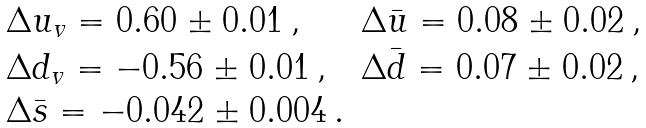Convert formula to latex. <formula><loc_0><loc_0><loc_500><loc_500>\begin{array} { l l } \Delta u _ { v } = 0 . 6 0 \pm 0 . 0 1 \, , & \Delta \bar { u } = 0 . 0 8 \pm 0 . 0 2 \, , \\ \Delta d _ { v } = - 0 . 5 6 \pm 0 . 0 1 \, , & \Delta \bar { d } = 0 . 0 7 \pm 0 . 0 2 \, , \\ \Delta \bar { s } = - 0 . 0 4 2 \pm 0 . 0 0 4 \, . & \\ \end{array}</formula> 